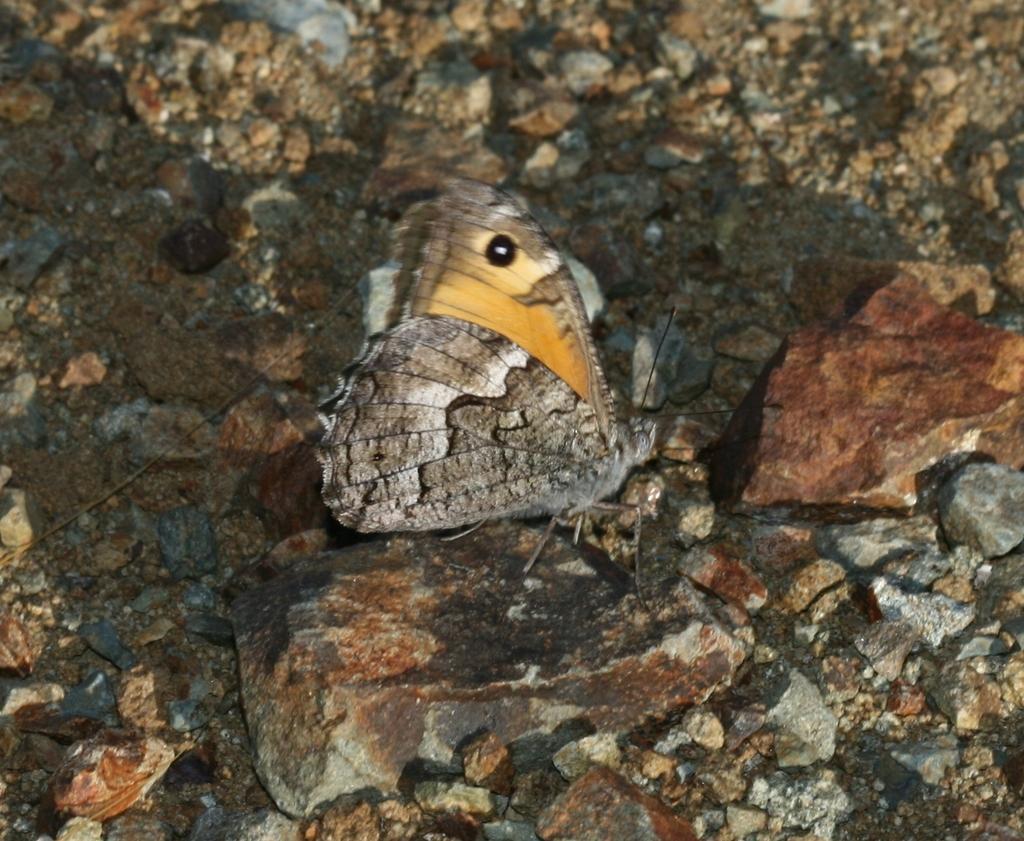Can you describe this image briefly? In this image I can see few stones and I can see a grey and yellow colour insect over here. 